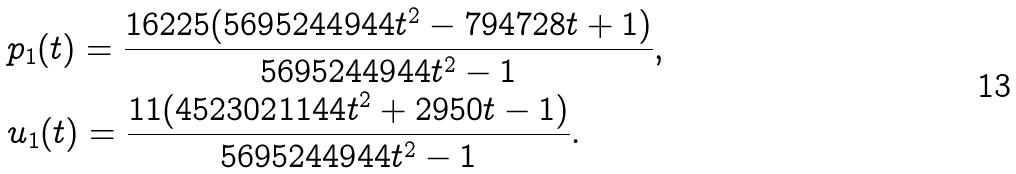Convert formula to latex. <formula><loc_0><loc_0><loc_500><loc_500>& p _ { 1 } ( t ) = \frac { 1 6 2 2 5 ( 5 6 9 5 2 4 4 9 4 4 t ^ { 2 } - 7 9 4 7 2 8 t + 1 ) } { 5 6 9 5 2 4 4 9 4 4 t ^ { 2 } - 1 } , \\ & u _ { 1 } ( t ) = \frac { 1 1 ( 4 5 2 3 0 2 1 1 4 4 t ^ { 2 } + 2 9 5 0 t - 1 ) } { 5 6 9 5 2 4 4 9 4 4 t ^ { 2 } - 1 } .</formula> 